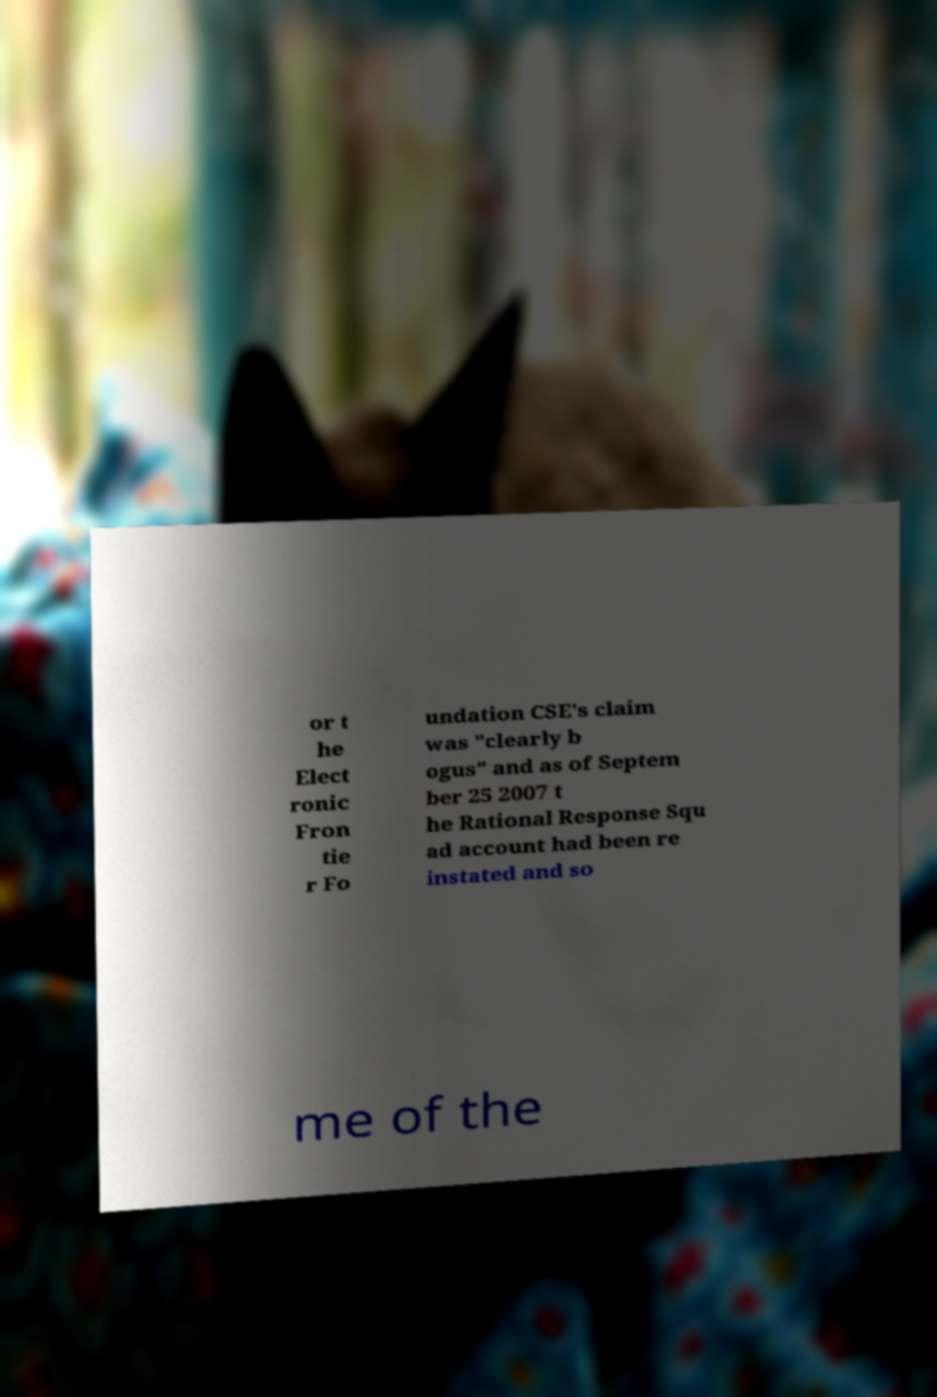Please read and relay the text visible in this image. What does it say? or t he Elect ronic Fron tie r Fo undation CSE's claim was "clearly b ogus" and as of Septem ber 25 2007 t he Rational Response Squ ad account had been re instated and so me of the 